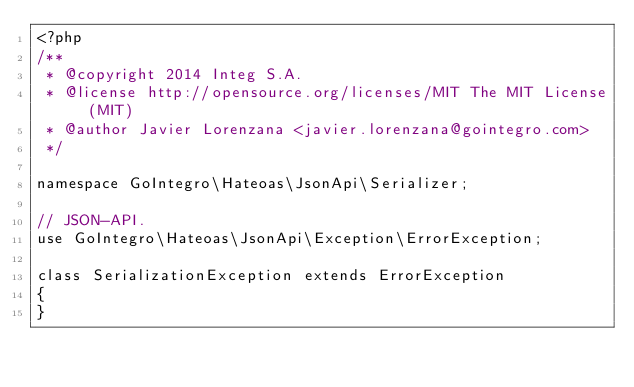<code> <loc_0><loc_0><loc_500><loc_500><_PHP_><?php
/**
 * @copyright 2014 Integ S.A.
 * @license http://opensource.org/licenses/MIT The MIT License (MIT)
 * @author Javier Lorenzana <javier.lorenzana@gointegro.com>
 */

namespace GoIntegro\Hateoas\JsonApi\Serializer;

// JSON-API.
use GoIntegro\Hateoas\JsonApi\Exception\ErrorException;

class SerializationException extends ErrorException
{
}
</code> 